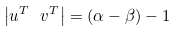<formula> <loc_0><loc_0><loc_500><loc_500>\left | u ^ { T } \ v ^ { T } \right | = ( \alpha - \beta ) - 1</formula> 